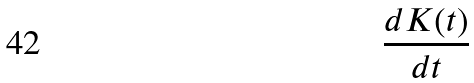Convert formula to latex. <formula><loc_0><loc_0><loc_500><loc_500>\frac { d K ( t ) } { d t }</formula> 